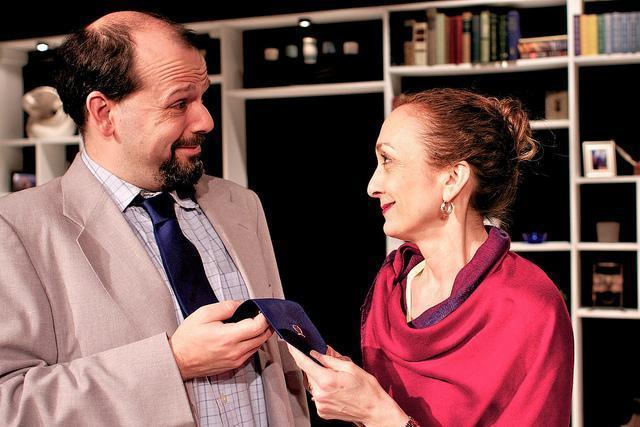How many books are there?
Give a very brief answer. 2. How many people are in the picture?
Give a very brief answer. 2. How many train tracks are in this picture?
Give a very brief answer. 0. 